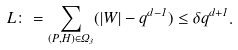<formula> <loc_0><loc_0><loc_500><loc_500>L \colon = \sum _ { ( P , H ) \in \Omega _ { 3 } } ( | W | - q ^ { d - 1 } ) \leq \delta q ^ { d + 1 } .</formula> 